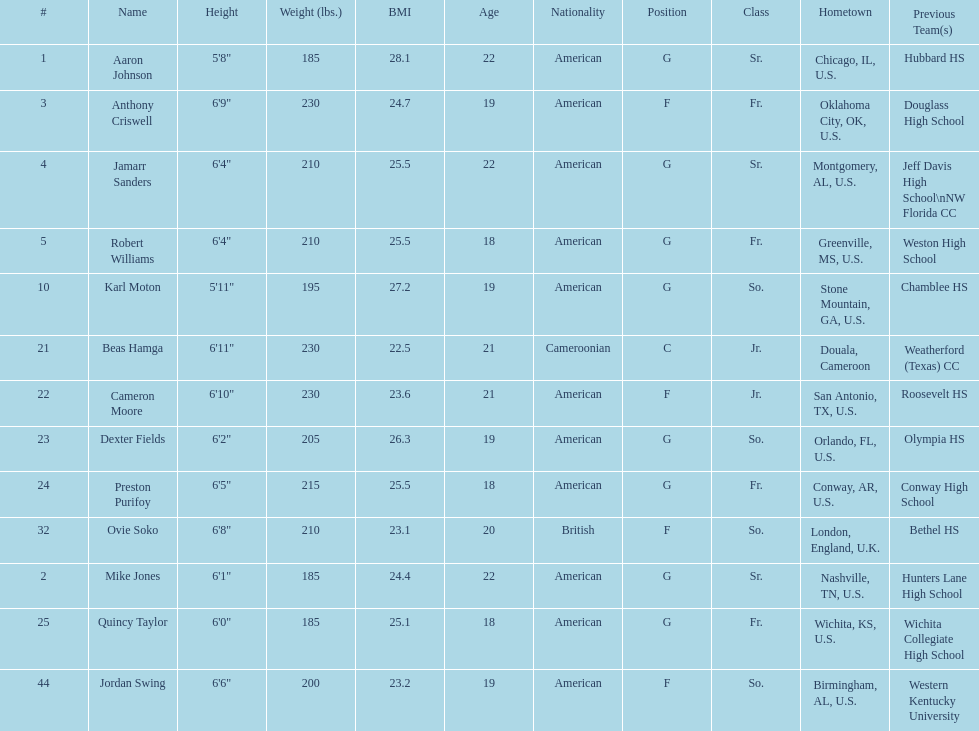Tell me the number of juniors on the team. 2. 